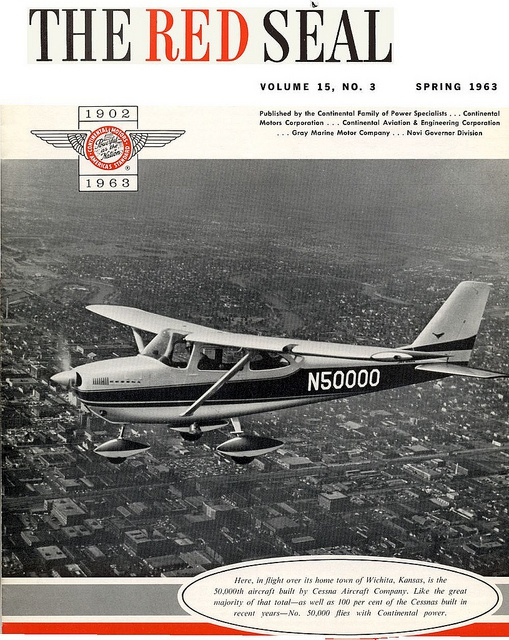Describe the objects in this image and their specific colors. I can see a airplane in white, black, darkgray, gray, and lightgray tones in this image. 